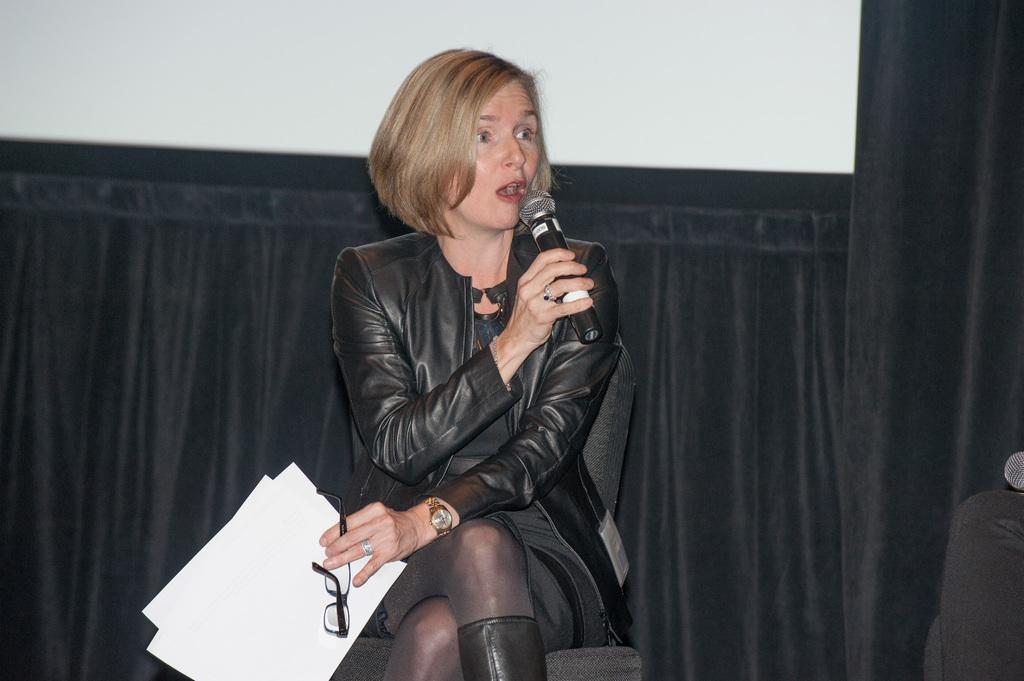What is the lady in the image doing? The lady is sitting on a chair and holding papers and a mic. What objects is the lady holding in her hands? The lady is holding papers and a mic. What accessories is the lady wearing? The lady is wearing glasses (specs) and a watch. What can be seen in the background of the image? There is a curtain in the background. What type of soup is being served in the image? There is no soup present in the image. What is the purpose of the property in the image? There is no property mentioned in the image; it features a lady sitting on a chair with papers and a mic. 